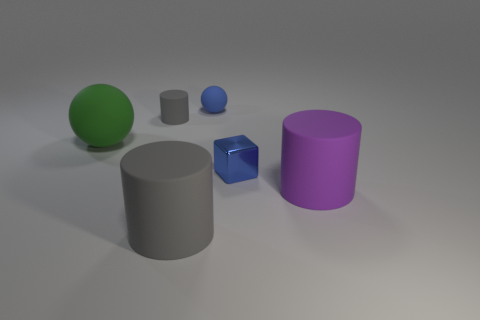Is the shape of the small metallic thing the same as the purple matte thing to the right of the large green sphere?
Your answer should be very brief. No. What is the color of the object that is both right of the tiny rubber sphere and behind the purple object?
Keep it short and to the point. Blue. There is a big cylinder in front of the cylinder that is right of the thing that is in front of the purple cylinder; what is its material?
Your answer should be very brief. Rubber. What is the material of the tiny cube?
Ensure brevity in your answer.  Metal. The blue matte thing that is the same shape as the large green thing is what size?
Keep it short and to the point. Small. Is the color of the large ball the same as the small ball?
Your answer should be very brief. No. What number of other things are made of the same material as the green object?
Make the answer very short. 4. Are there the same number of small blue metal things that are right of the purple thing and blue spheres?
Offer a terse response. No. There is a gray matte cylinder that is behind the blue metallic cube; does it have the same size as the small metal object?
Provide a succinct answer. Yes. How many large purple objects are left of the small blue cube?
Give a very brief answer. 0. 